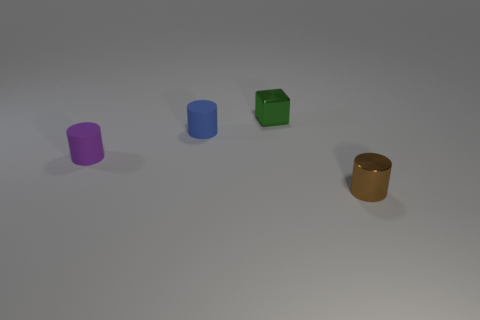Subtract all rubber cylinders. How many cylinders are left? 1 Add 4 green metallic balls. How many objects exist? 8 Subtract all cylinders. How many objects are left? 1 Subtract 0 gray cylinders. How many objects are left? 4 Subtract all tiny brown metallic cylinders. Subtract all matte things. How many objects are left? 1 Add 4 blue matte cylinders. How many blue matte cylinders are left? 5 Add 4 large green balls. How many large green balls exist? 4 